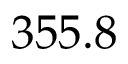Convert formula to latex. <formula><loc_0><loc_0><loc_500><loc_500>3 5 5 . 8</formula> 